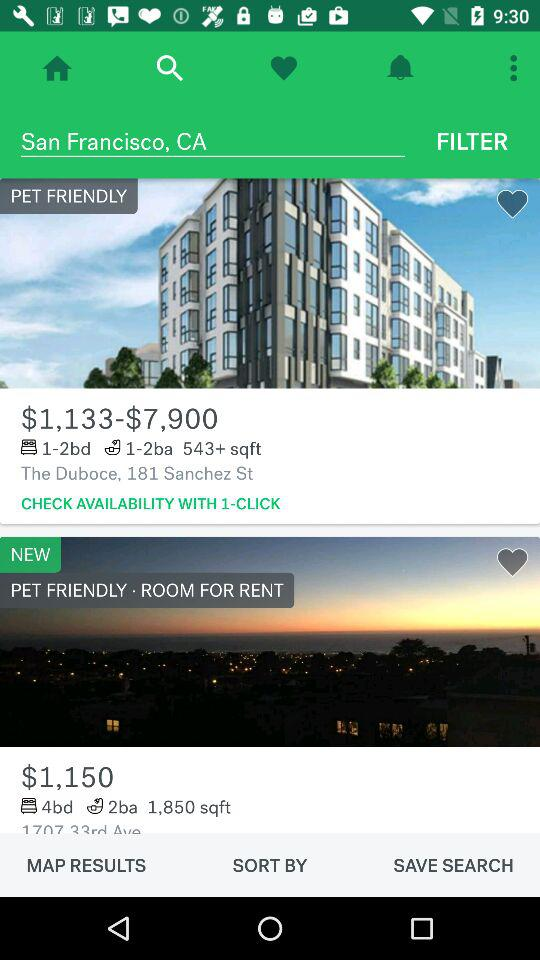What is the price range of rooms located at "The Duboce", 181 Sanchez St.? The price ranges from $1,133 to $7,900. 